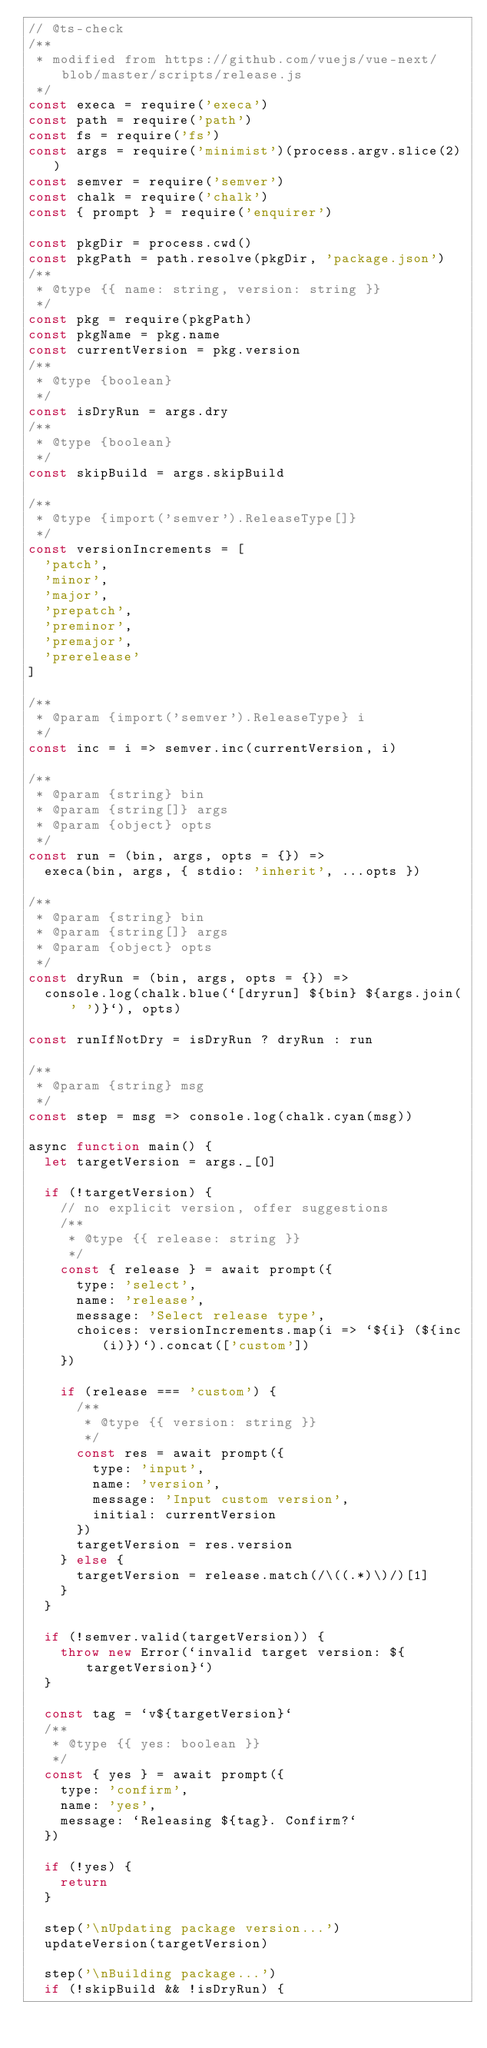<code> <loc_0><loc_0><loc_500><loc_500><_JavaScript_>// @ts-check
/**
 * modified from https://github.com/vuejs/vue-next/blob/master/scripts/release.js
 */
const execa = require('execa')
const path = require('path')
const fs = require('fs')
const args = require('minimist')(process.argv.slice(2))
const semver = require('semver')
const chalk = require('chalk')
const { prompt } = require('enquirer')

const pkgDir = process.cwd()
const pkgPath = path.resolve(pkgDir, 'package.json')
/**
 * @type {{ name: string, version: string }}
 */
const pkg = require(pkgPath)
const pkgName = pkg.name
const currentVersion = pkg.version
/**
 * @type {boolean}
 */
const isDryRun = args.dry
/**
 * @type {boolean}
 */
const skipBuild = args.skipBuild

/**
 * @type {import('semver').ReleaseType[]}
 */
const versionIncrements = [
  'patch',
  'minor',
  'major',
  'prepatch',
  'preminor',
  'premajor',
  'prerelease'
]

/**
 * @param {import('semver').ReleaseType} i
 */
const inc = i => semver.inc(currentVersion, i)

/**
 * @param {string} bin
 * @param {string[]} args
 * @param {object} opts
 */
const run = (bin, args, opts = {}) =>
  execa(bin, args, { stdio: 'inherit', ...opts })

/**
 * @param {string} bin
 * @param {string[]} args
 * @param {object} opts
 */
const dryRun = (bin, args, opts = {}) =>
  console.log(chalk.blue(`[dryrun] ${bin} ${args.join(' ')}`), opts)

const runIfNotDry = isDryRun ? dryRun : run

/**
 * @param {string} msg
 */
const step = msg => console.log(chalk.cyan(msg))

async function main() {
  let targetVersion = args._[0]

  if (!targetVersion) {
    // no explicit version, offer suggestions
    /**
     * @type {{ release: string }}
     */
    const { release } = await prompt({
      type: 'select',
      name: 'release',
      message: 'Select release type',
      choices: versionIncrements.map(i => `${i} (${inc(i)})`).concat(['custom'])
    })

    if (release === 'custom') {
      /**
       * @type {{ version: string }}
       */
      const res = await prompt({
        type: 'input',
        name: 'version',
        message: 'Input custom version',
        initial: currentVersion
      })
      targetVersion = res.version
    } else {
      targetVersion = release.match(/\((.*)\)/)[1]
    }
  }

  if (!semver.valid(targetVersion)) {
    throw new Error(`invalid target version: ${targetVersion}`)
  }

  const tag = `v${targetVersion}`
  /**
   * @type {{ yes: boolean }}
   */
  const { yes } = await prompt({
    type: 'confirm',
    name: 'yes',
    message: `Releasing ${tag}. Confirm?`
  })

  if (!yes) {
    return
  }

  step('\nUpdating package version...')
  updateVersion(targetVersion)

  step('\nBuilding package...')
  if (!skipBuild && !isDryRun) {</code> 